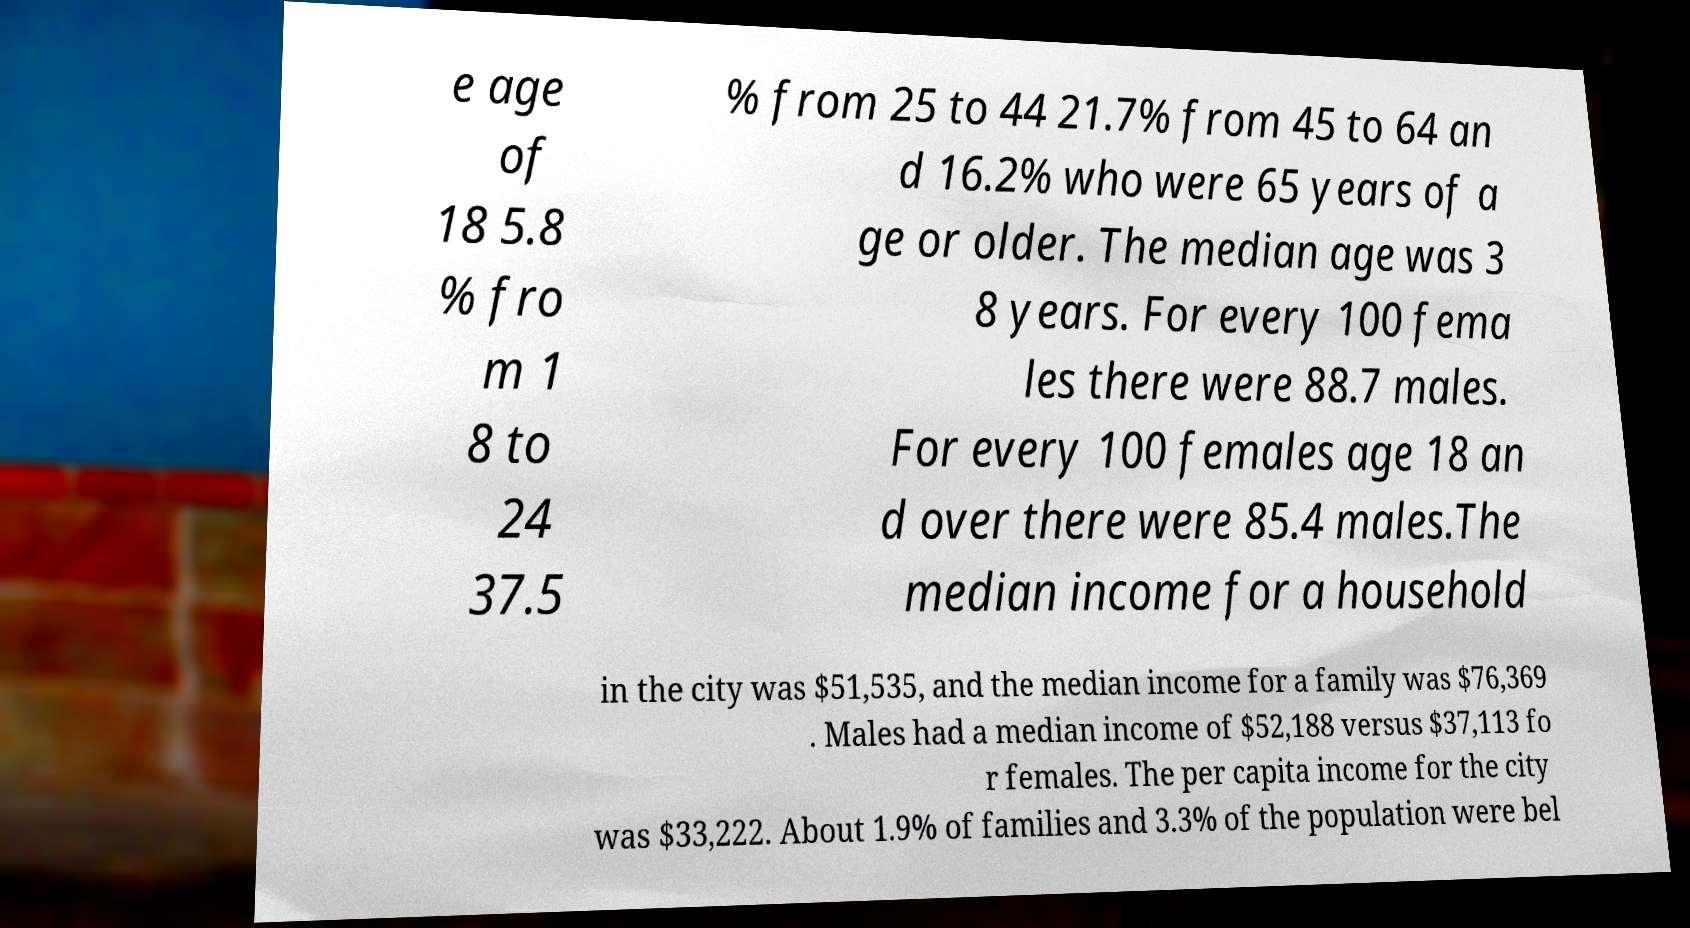I need the written content from this picture converted into text. Can you do that? e age of 18 5.8 % fro m 1 8 to 24 37.5 % from 25 to 44 21.7% from 45 to 64 an d 16.2% who were 65 years of a ge or older. The median age was 3 8 years. For every 100 fema les there were 88.7 males. For every 100 females age 18 an d over there were 85.4 males.The median income for a household in the city was $51,535, and the median income for a family was $76,369 . Males had a median income of $52,188 versus $37,113 fo r females. The per capita income for the city was $33,222. About 1.9% of families and 3.3% of the population were bel 